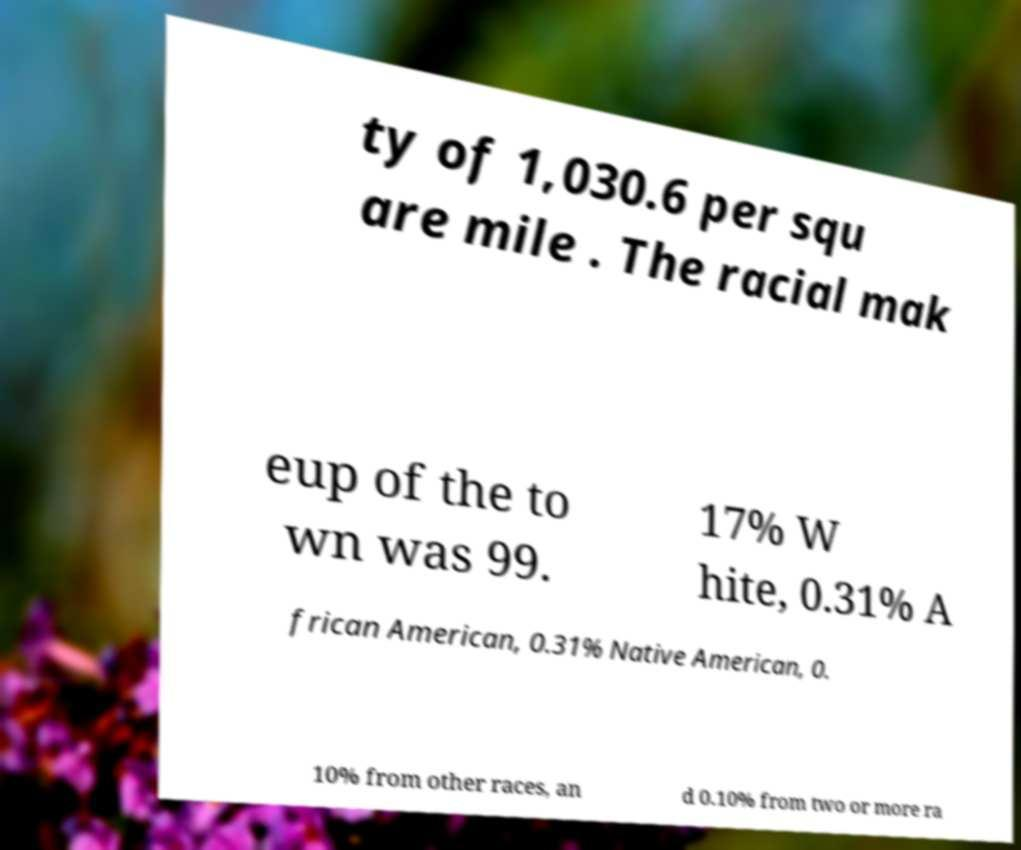For documentation purposes, I need the text within this image transcribed. Could you provide that? ty of 1,030.6 per squ are mile . The racial mak eup of the to wn was 99. 17% W hite, 0.31% A frican American, 0.31% Native American, 0. 10% from other races, an d 0.10% from two or more ra 